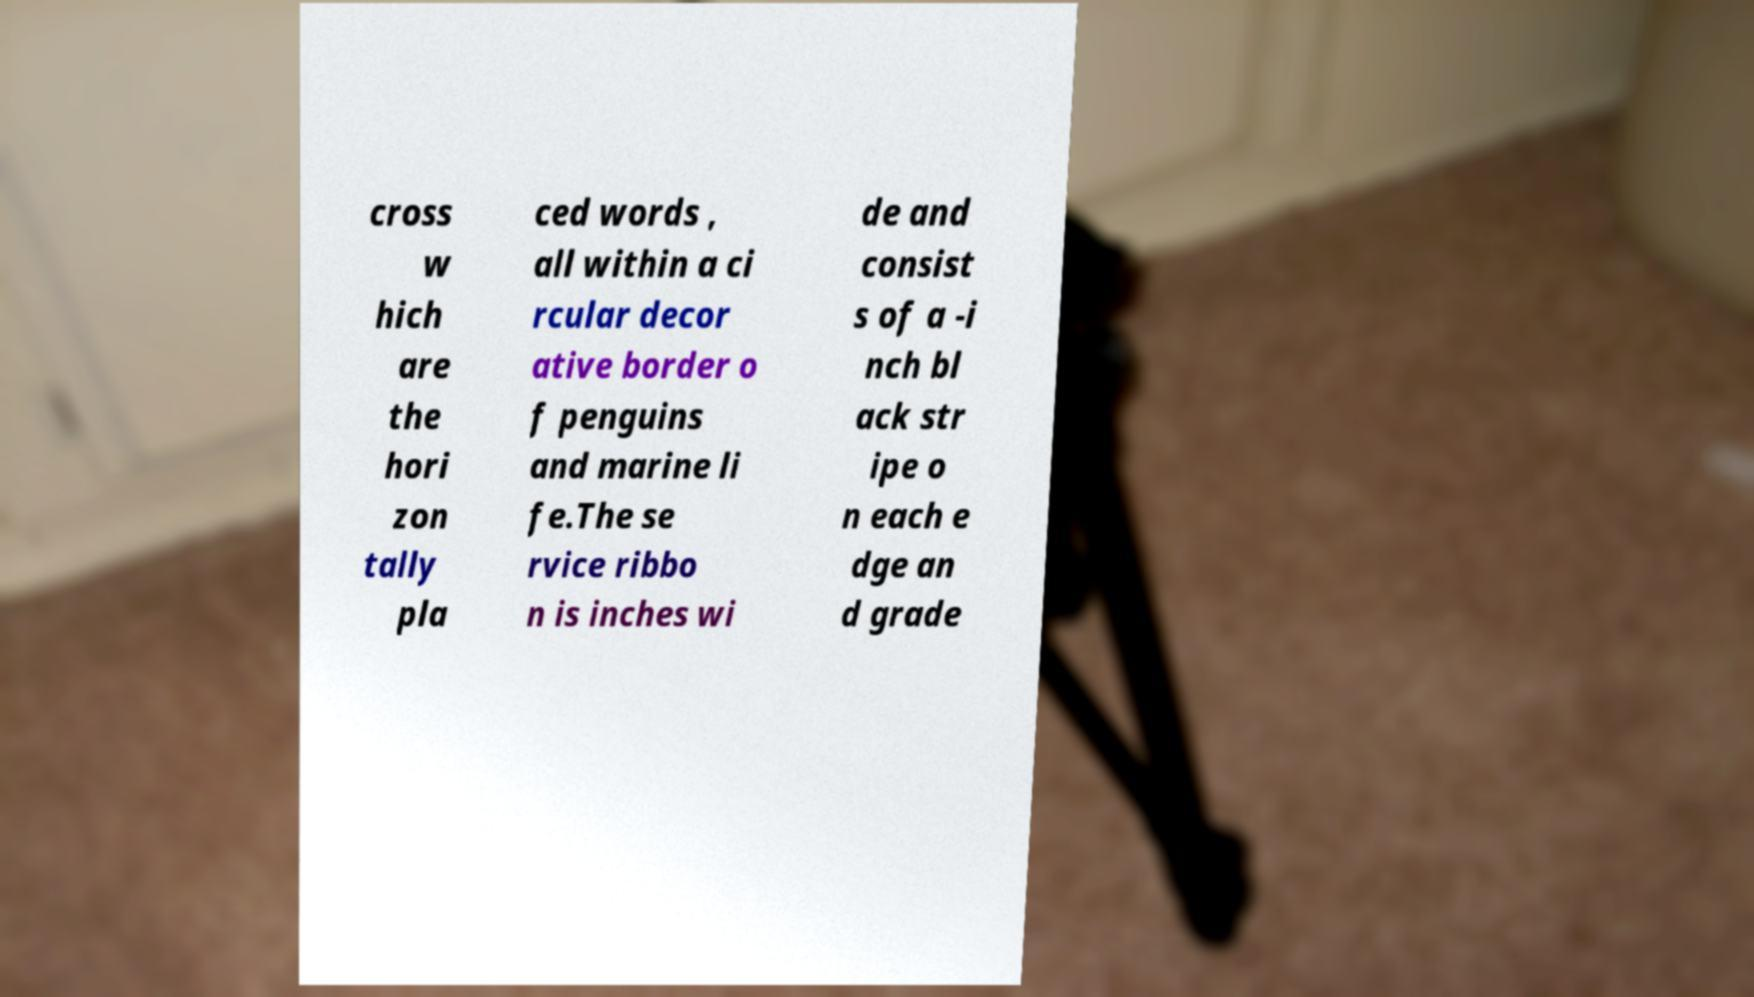I need the written content from this picture converted into text. Can you do that? cross w hich are the hori zon tally pla ced words , all within a ci rcular decor ative border o f penguins and marine li fe.The se rvice ribbo n is inches wi de and consist s of a -i nch bl ack str ipe o n each e dge an d grade 